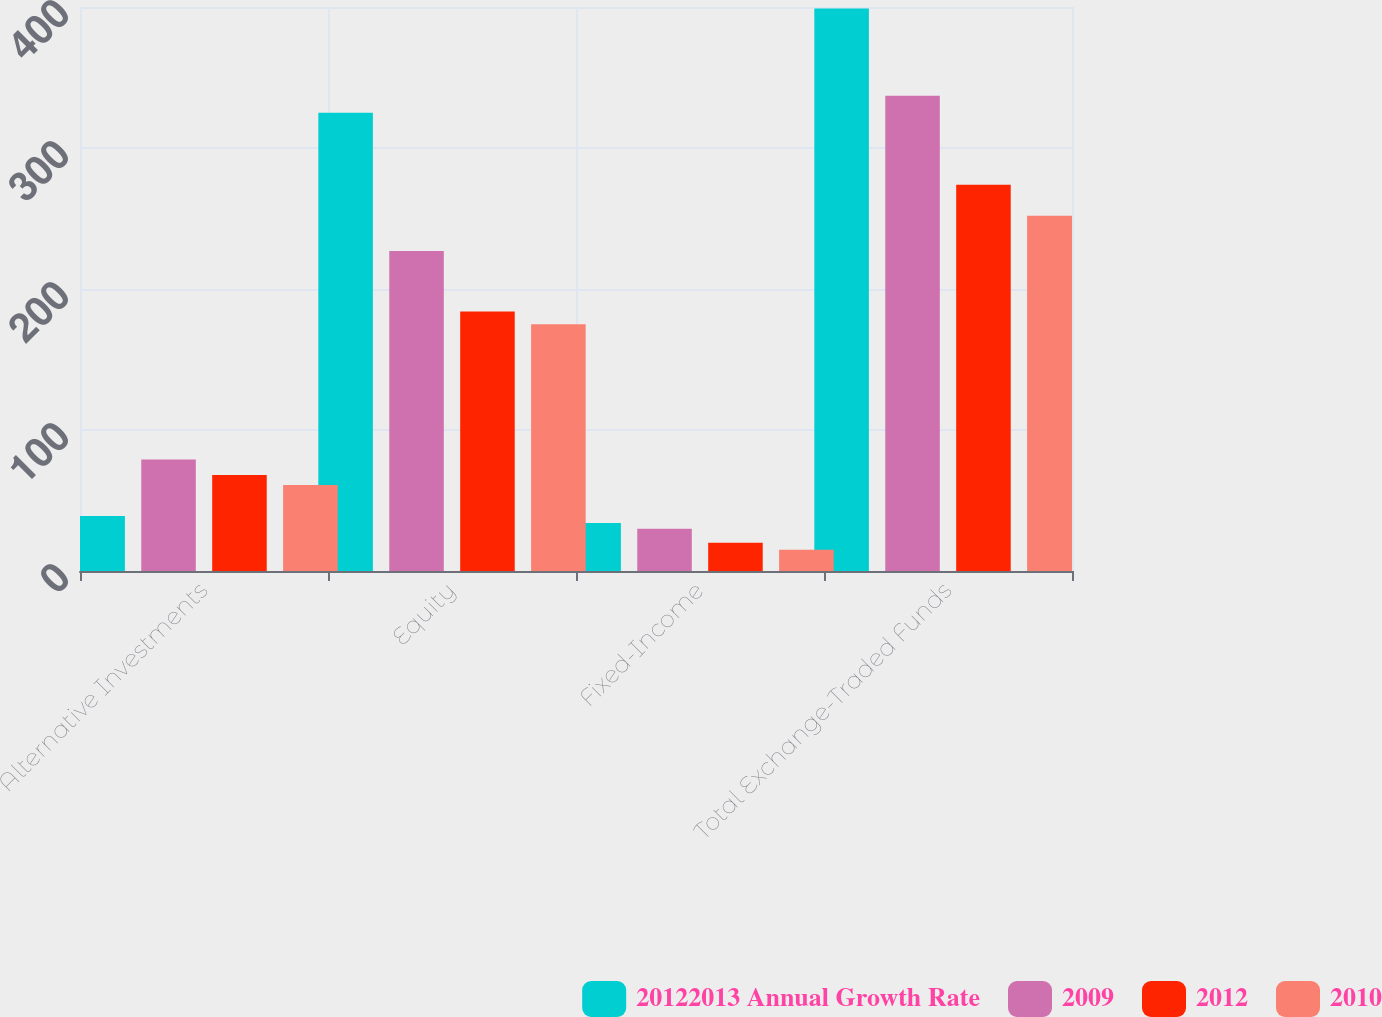Convert chart to OTSL. <chart><loc_0><loc_0><loc_500><loc_500><stacked_bar_chart><ecel><fcel>Alternative Investments<fcel>Equity<fcel>Fixed-Income<fcel>Total Exchange-Traded Funds<nl><fcel>20122013 Annual Growth Rate<fcel>39<fcel>325<fcel>34<fcel>399<nl><fcel>2009<fcel>79<fcel>227<fcel>30<fcel>337<nl><fcel>2012<fcel>68<fcel>184<fcel>20<fcel>274<nl><fcel>2010<fcel>61<fcel>175<fcel>15<fcel>252<nl></chart> 